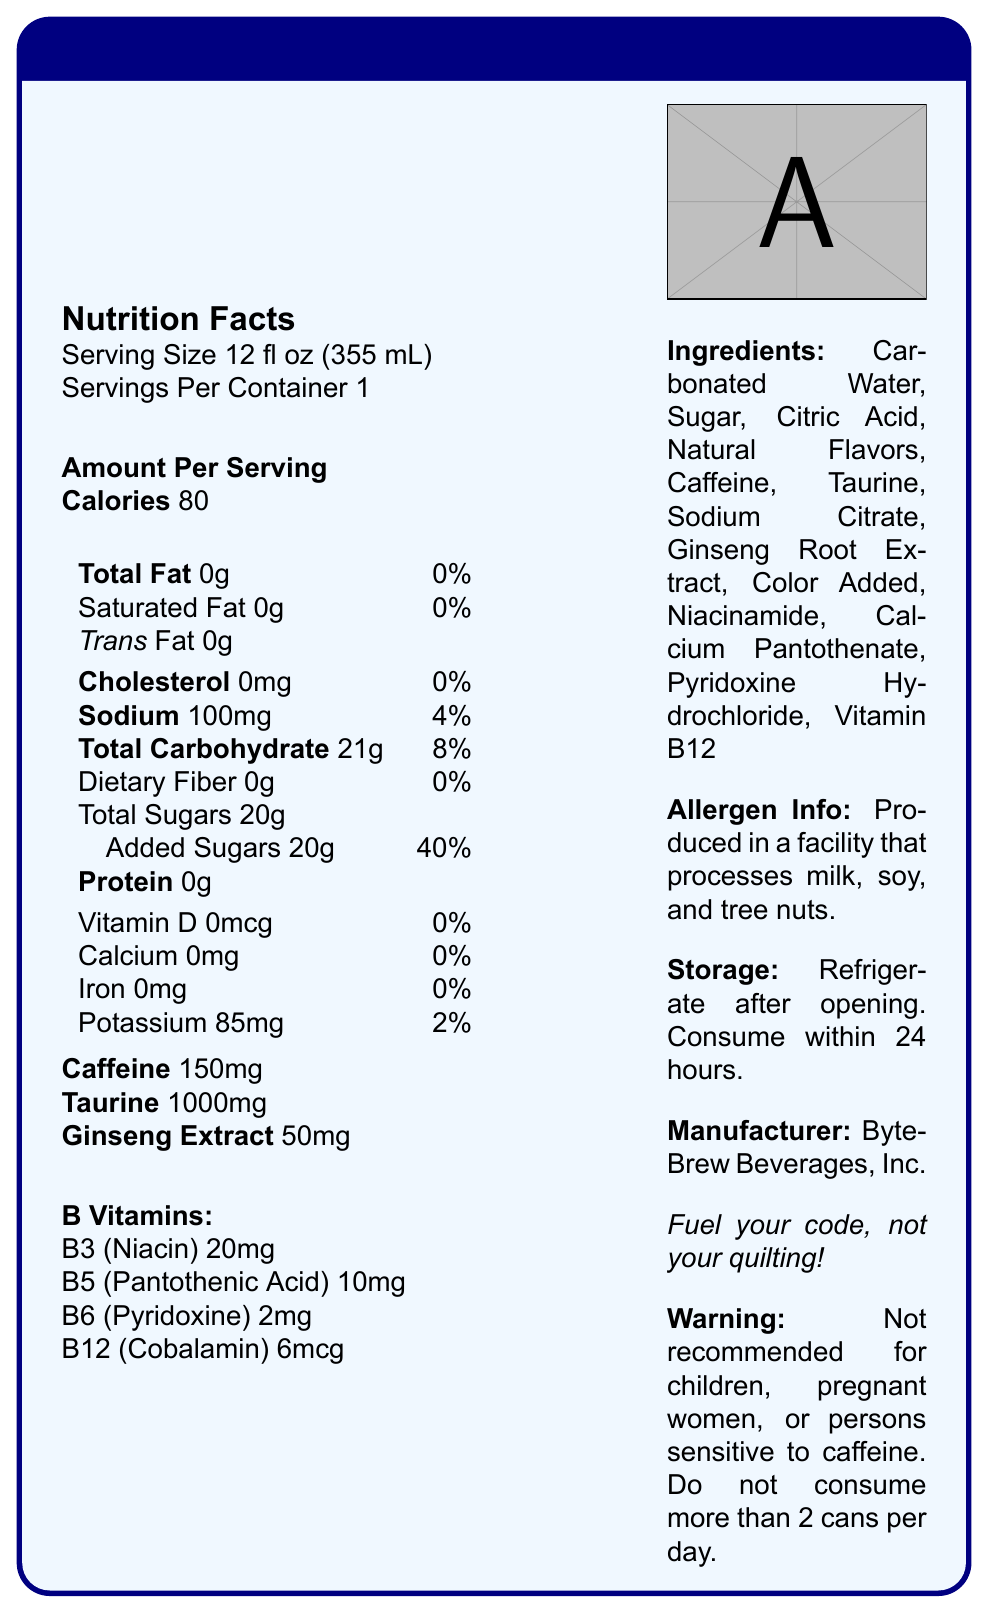What is the serving size of CodeFuel? The serving size information is provided in the nutrition facts section and states it is 12 fl oz (355 mL).
Answer: 12 fl oz (355 mL) How much caffeine is in one serving of CodeFuel? The document specifies that there are 150mg of caffeine per serving.
Answer: 150mg What is the amount of sodium in one serving? According to the nutrition facts, one serving contains 100mg of sodium.
Answer: 100mg What are the total carbohydrates in one serving? The nutrition facts show that there are 21g of total carbohydrates in one serving.
Answer: 21g Which company manufactures CodeFuel? The manufacturer’s name, ByteBrew Beverages, Inc., is listed under the manufacturer information.
Answer: ByteBrew Beverages, Inc. How many grams of added sugars are in one serving? The label states that there are 20g of added sugars in one serving.
Answer: 20g What percentage of daily value does sodium contribute? The sodium content contributes to 4% of the daily value.
Answer: 4% How many types of B vitamins are listed in the document? The B vitamins listed are B3 (Niacin), B5 (Pantothenic Acid), B6 (Pyridoxine), and B12 (Cobalamin).
Answer: Four types (B3, B5, B6, B12) What is the tagline of CodeFuel? The tagline of CodeFuel is mentioned as "Fuel your code, not your quilting!"
Answer: Fuel your code, not your quilting! Which of the following is not in the list of ingredients of CodeFuel? A. Taurine B. Vitamin C C. Citric Acid D. Niacinamide The ingredients do not list Vitamin C. Instead, they include Taurine, Citric Acid, and Niacinamide.
Answer: B. Vitamin C How many servings per container does CodeFuel have? A. 1 B. 2 C. 3 D. 4 The document specifies that there is 1 serving per container.
Answer: A. 1 True or False: CodeFuel is recommended for children. The warning section mentions that it is not recommended for children.
Answer: False What is the main idea of the document? The document consists of information regarding the nutritional content, ingredients, serving size, manufacturer, allergen info, storage instructions, and warnings about the product.
Answer: The document provides detailed nutrition facts and ingredient information about CodeFuel, a caffeine-infused energy drink targeted toward software developers. How much sugar is in the beverage? The document states the total sugars but does not specify the breakdown between different types of sugar other than added sugars.
Answer: Cannot be determined What is the warning regarding consumption? The warning section provides this specific caution about who should avoid the beverage and consumption limits.
Answer: Not recommended for children, pregnant women, or persons sensitive to caffeine. Do not consume more than 2 cans per day. List three main ingredients in CodeFuel. The document lists Carbonated Water, Sugar, and Citric Acid as the first three ingredients.
Answer: Carbonated Water, Sugar, Citric Acid Does the product contain any protein? The nutrition facts clearly mention 0g of protein.
Answer: No 